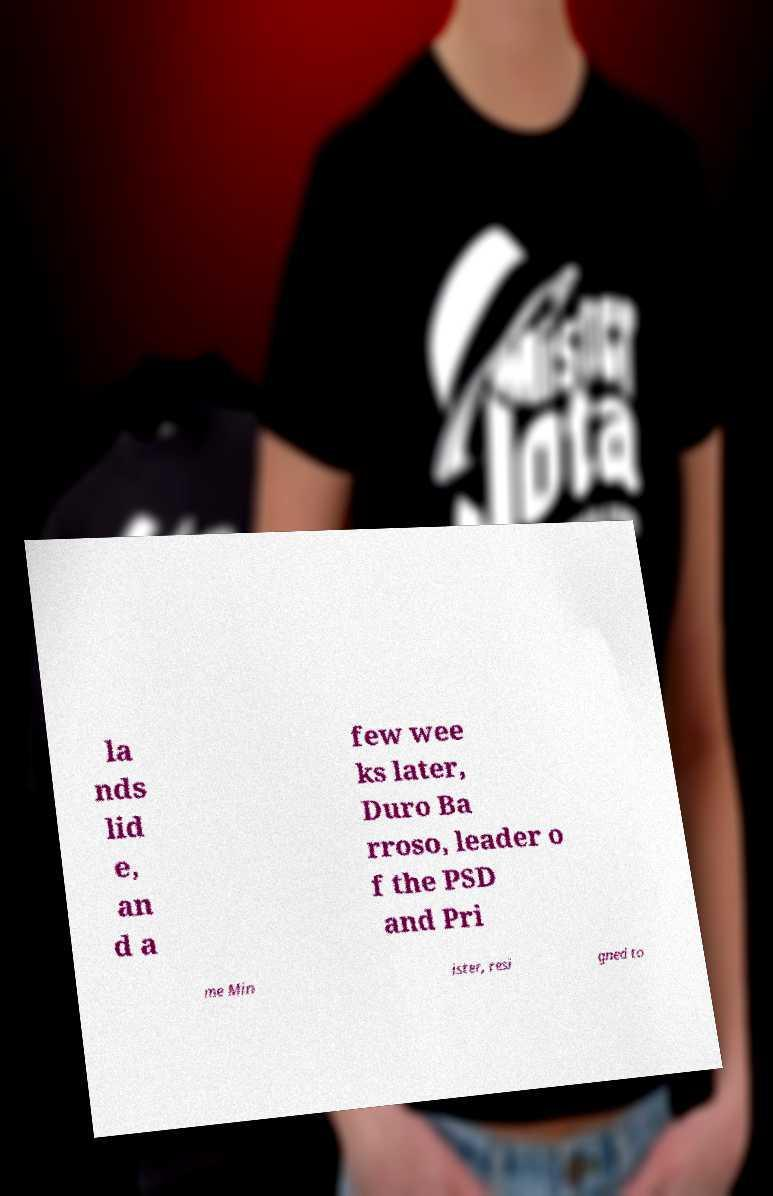Please read and relay the text visible in this image. What does it say? la nds lid e, an d a few wee ks later, Duro Ba rroso, leader o f the PSD and Pri me Min ister, resi gned to 